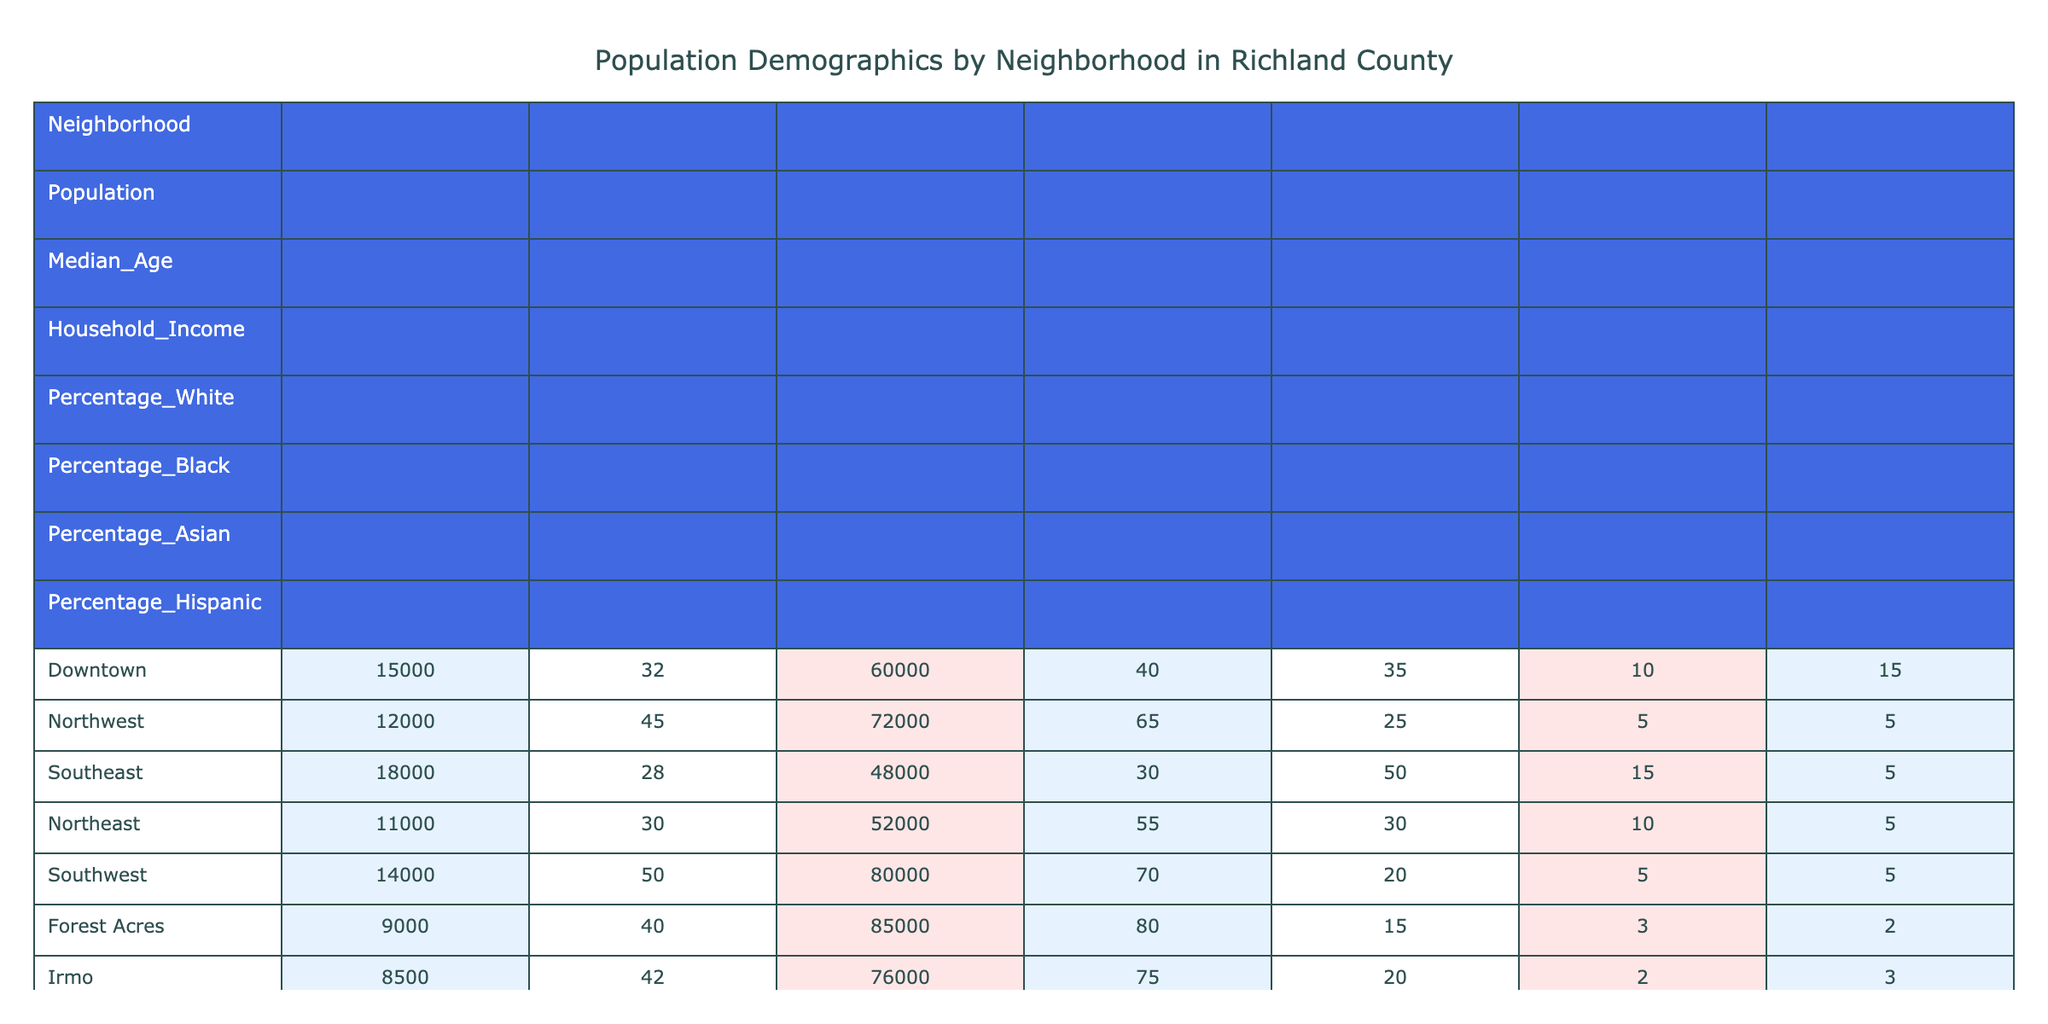What is the population of Downtown? The table lists the population for each neighborhood, and for Downtown, it shows a population of 15,000.
Answer: 15,000 What is the median age in the Northwest neighborhood? According to the table, the median age for the Northwest neighborhood is provided directly as 45 years.
Answer: 45 Which neighborhood has the highest household income? By comparing the household income values across all neighborhoods, the highest is 85,000 in Forest Acres.
Answer: Forest Acres What is the average percentage of White residents across all neighborhoods? To find this, sum the percentage of White residents: (40 + 65 + 30 + 55 + 70 + 80 + 75 + 85 + 50 + 35) =  685. There are 10 neighborhoods, so 685/10 = 68.5%.
Answer: 68.5% Is the percentage of Hispanic residents higher in Southeast than in Northeast? The Southeast neighborhood has a percentage of Hispanic residents of 5%, while Northeast has the same percentage of 5%. So, the statement is false because they are equal.
Answer: No Which neighborhood has the lowest percentage of Black residents? By reviewing the percentages for Black residents, Blythewood has the lowest at 10%.
Answer: Blythewood What is the total population of neighborhoods with a median age over 40? The neighborhoods with median ages over 40 are Northwest, Southwest, Forest Acres, and Irmo. Their populations are 12,000 (Northwest) + 14,000 (Southwest) + 9,000 (Forest Acres) + 8,500 (Irmo) = 43,500.
Answer: 43,500 Are there more Asian residents in Southeast than in Northwest? The table shows that Southeast has 15% Asian residents while Northwest has only 5%. Thus, Southeast has a higher percentage of Asian residents.
Answer: Yes What is the difference in median age between the oldest and youngest neighborhoods? The oldest neighborhood is Southwest with a median age of 50, and the youngest is Southeast with a median age of 28. The difference is 50 - 28 = 22 years.
Answer: 22 years 